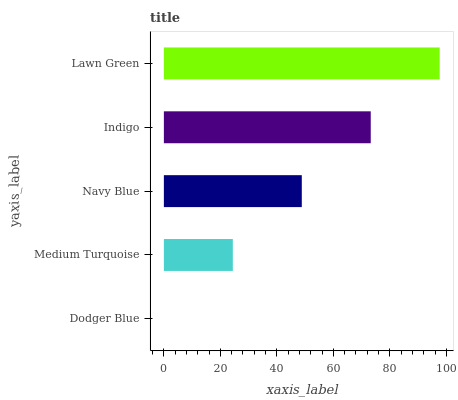Is Dodger Blue the minimum?
Answer yes or no. Yes. Is Lawn Green the maximum?
Answer yes or no. Yes. Is Medium Turquoise the minimum?
Answer yes or no. No. Is Medium Turquoise the maximum?
Answer yes or no. No. Is Medium Turquoise greater than Dodger Blue?
Answer yes or no. Yes. Is Dodger Blue less than Medium Turquoise?
Answer yes or no. Yes. Is Dodger Blue greater than Medium Turquoise?
Answer yes or no. No. Is Medium Turquoise less than Dodger Blue?
Answer yes or no. No. Is Navy Blue the high median?
Answer yes or no. Yes. Is Navy Blue the low median?
Answer yes or no. Yes. Is Dodger Blue the high median?
Answer yes or no. No. Is Indigo the low median?
Answer yes or no. No. 